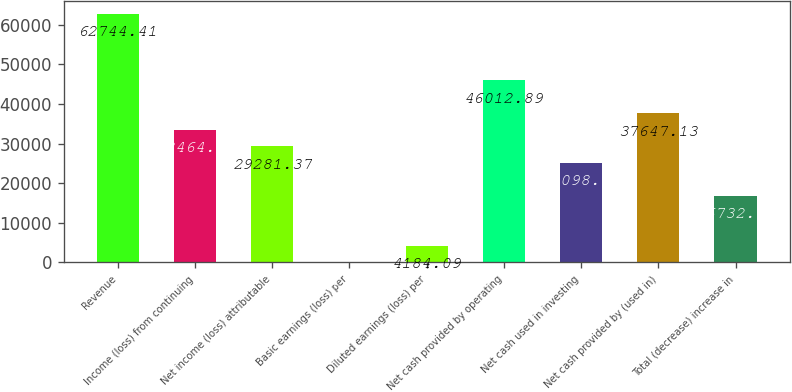<chart> <loc_0><loc_0><loc_500><loc_500><bar_chart><fcel>Revenue<fcel>Income (loss) from continuing<fcel>Net income (loss) attributable<fcel>Basic earnings (loss) per<fcel>Diluted earnings (loss) per<fcel>Net cash provided by operating<fcel>Net cash used in investing<fcel>Net cash provided by (used in)<fcel>Total (decrease) increase in<nl><fcel>62744.4<fcel>33464.2<fcel>29281.4<fcel>1.21<fcel>4184.09<fcel>46012.9<fcel>25098.5<fcel>37647.1<fcel>16732.7<nl></chart> 